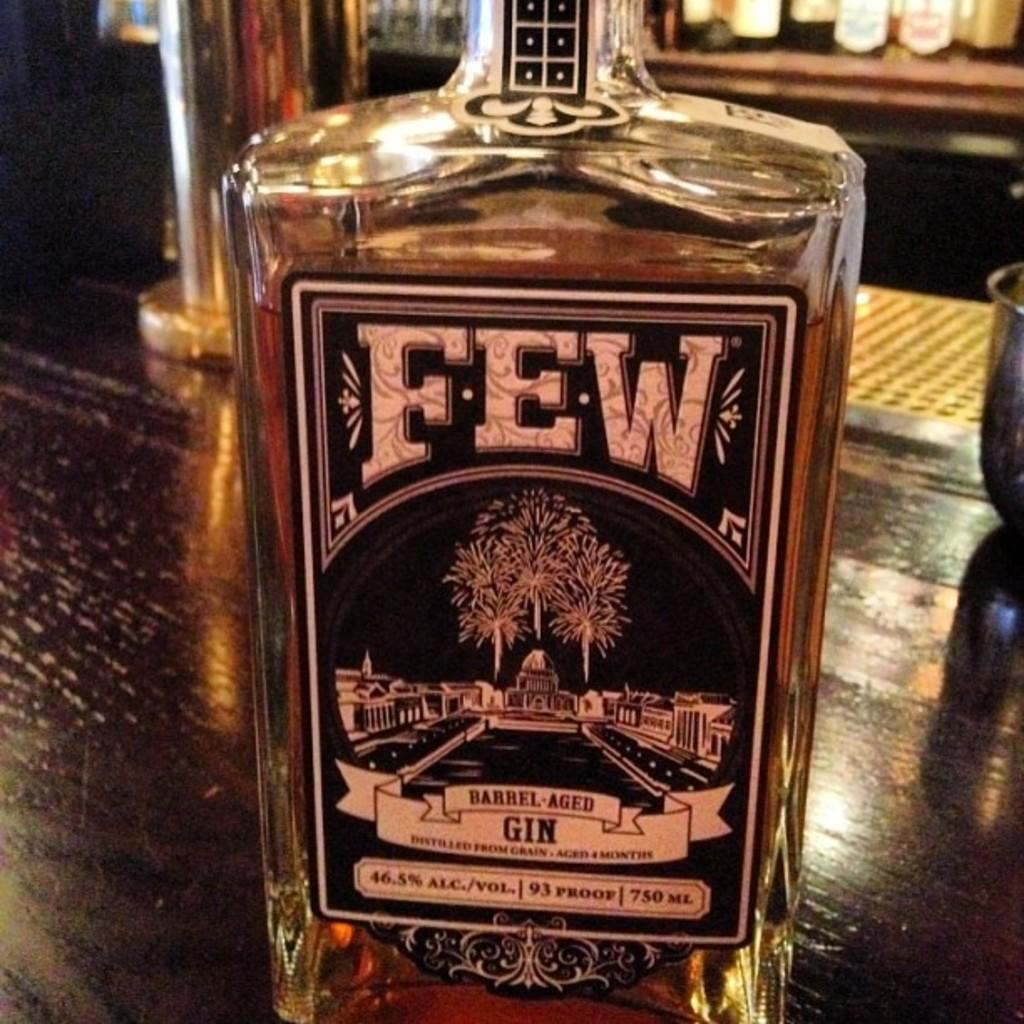<image>
Relay a brief, clear account of the picture shown. A bottle of few gin sits on a wooden bar. 